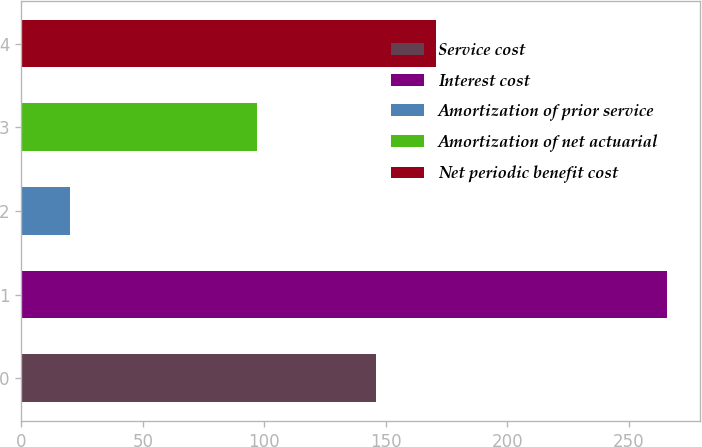Convert chart. <chart><loc_0><loc_0><loc_500><loc_500><bar_chart><fcel>Service cost<fcel>Interest cost<fcel>Amortization of prior service<fcel>Amortization of net actuarial<fcel>Net periodic benefit cost<nl><fcel>146<fcel>266<fcel>20<fcel>97<fcel>170.6<nl></chart> 